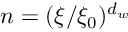Convert formula to latex. <formula><loc_0><loc_0><loc_500><loc_500>n = ( \xi / \xi _ { 0 } ) ^ { d _ { w } }</formula> 